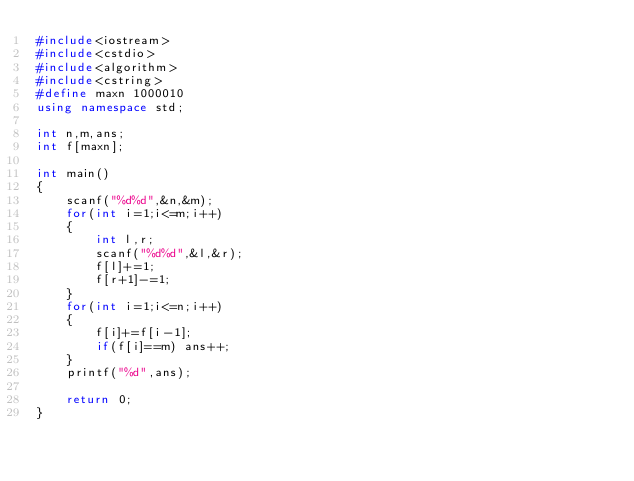<code> <loc_0><loc_0><loc_500><loc_500><_C++_>#include<iostream>
#include<cstdio>
#include<algorithm>
#include<cstring>
#define maxn 1000010
using namespace std;

int n,m,ans;
int f[maxn];

int main()
{
	scanf("%d%d",&n,&m);
	for(int i=1;i<=m;i++) 
	{
		int l,r;
		scanf("%d%d",&l,&r);
		f[l]+=1;
		f[r+1]-=1;
	}
	for(int i=1;i<=n;i++)
	{
		f[i]+=f[i-1];
		if(f[i]==m) ans++;
	} 
	printf("%d",ans);
	
	return 0;
}</code> 